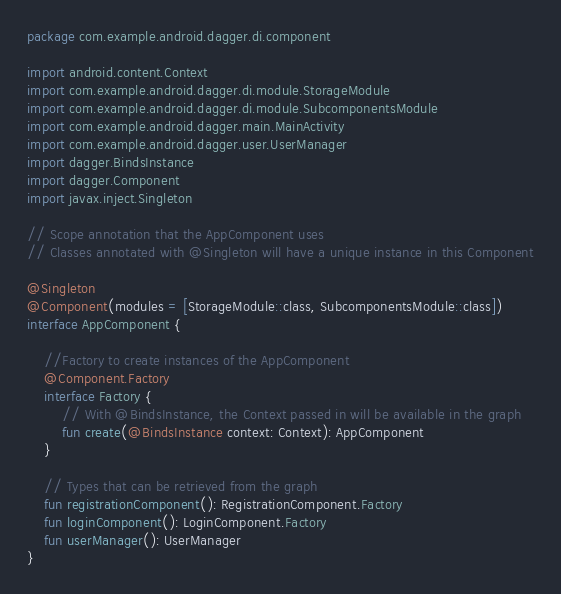<code> <loc_0><loc_0><loc_500><loc_500><_Kotlin_>package com.example.android.dagger.di.component

import android.content.Context
import com.example.android.dagger.di.module.StorageModule
import com.example.android.dagger.di.module.SubcomponentsModule
import com.example.android.dagger.main.MainActivity
import com.example.android.dagger.user.UserManager
import dagger.BindsInstance
import dagger.Component
import javax.inject.Singleton

// Scope annotation that the AppComponent uses
// Classes annotated with @Singleton will have a unique instance in this Component

@Singleton
@Component(modules = [StorageModule::class, SubcomponentsModule::class])
interface AppComponent {

    //Factory to create instances of the AppComponent
    @Component.Factory
    interface Factory {
        // With @BindsInstance, the Context passed in will be available in the graph
        fun create(@BindsInstance context: Context): AppComponent
    }

    // Types that can be retrieved from the graph
    fun registrationComponent(): RegistrationComponent.Factory
    fun loginComponent(): LoginComponent.Factory
    fun userManager(): UserManager
}</code> 